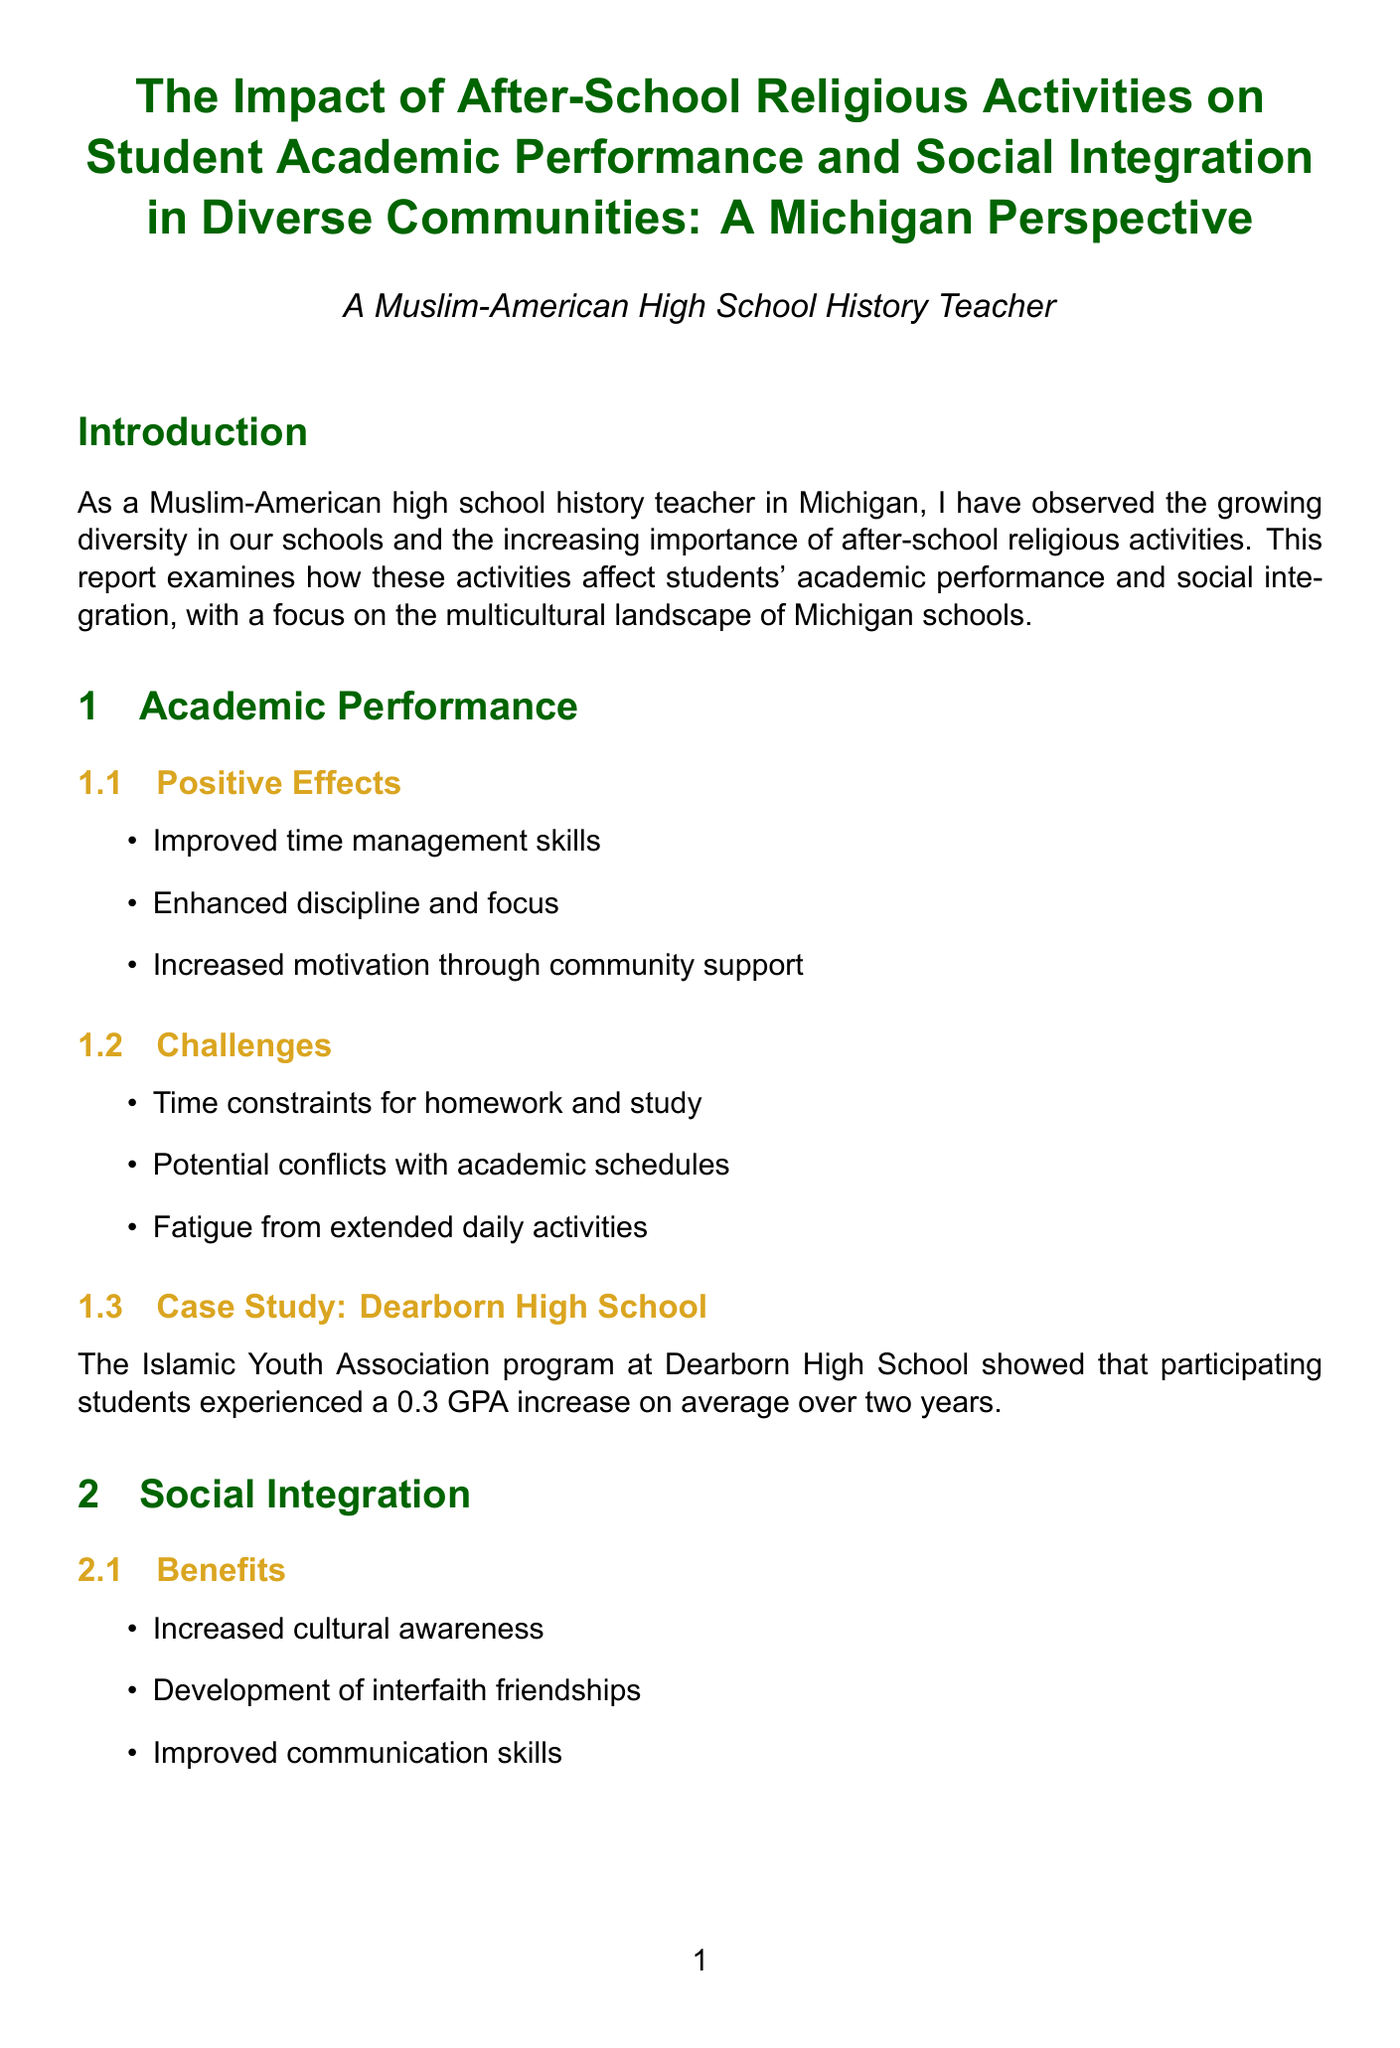What is the title of the report? The title of the report is stated at the beginning of the document.
Answer: The Impact of After-School Religious Activities on Student Academic Performance and Social Integration in Diverse Communities: A Michigan Perspective What program showed a GPA increase at Dearborn High School? The specific program that was studied is mentioned in the section on academic performance.
Answer: Islamic Youth Association What was the average GPA increase reported in the case study? The document lists a specific increase in GPA related to the case study.
Answer: 0.3 What community initiative reduced incidents of religious-based bullying? The report highlights a community initiative that addressed bullying through its programs.
Answer: Interfaith Youth Alliance of Grand Rapids What percentage of Michigan's student population is African American? The demographic breakdown provides specific percentages for different racial groups.
Answer: 18% Name one successful program that promotes interfaith dialogue in Michigan schools. The document lists programs that facilitate interfaith activities.
Answer: Ann Arbor Interfaith Council for Youth What is one benefit of after-school religious activities mentioned in the report? Benefits are outlined in the social integration section of the document.
Answer: Increased cultural awareness What recommendation involves collaboration? The recommendations section suggests specific actions to enhance program impact.
Answer: Encourage collaboration between religious organizations and schools for academic support 